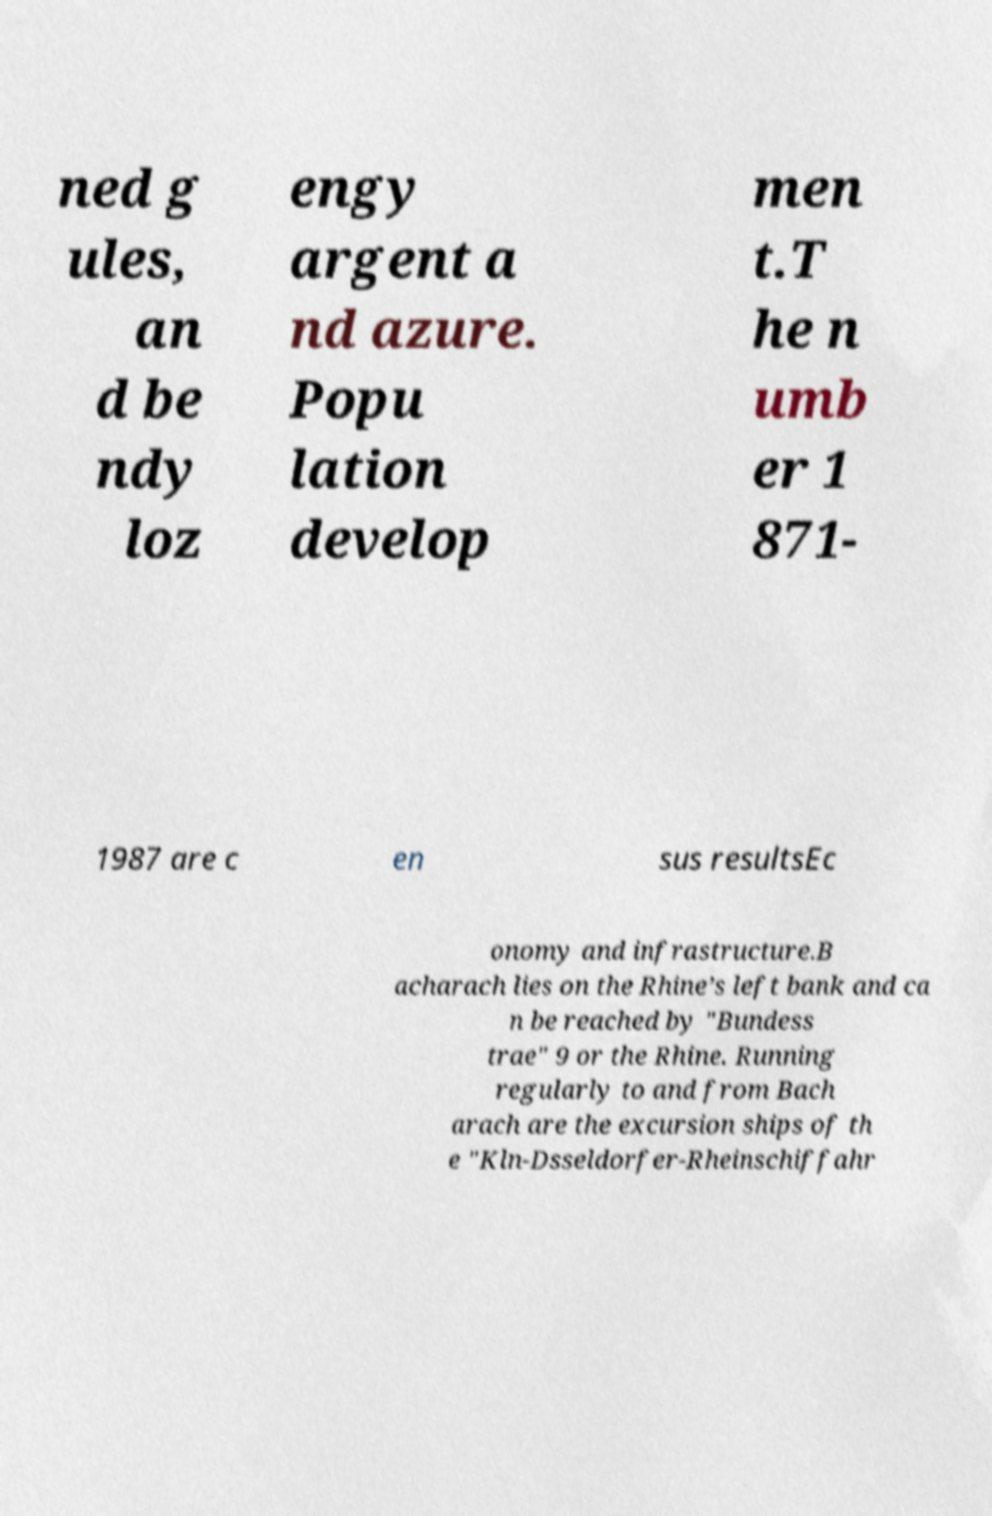What messages or text are displayed in this image? I need them in a readable, typed format. ned g ules, an d be ndy loz engy argent a nd azure. Popu lation develop men t.T he n umb er 1 871- 1987 are c en sus resultsEc onomy and infrastructure.B acharach lies on the Rhine’s left bank and ca n be reached by "Bundess trae" 9 or the Rhine. Running regularly to and from Bach arach are the excursion ships of th e "Kln-Dsseldorfer-Rheinschiffahr 